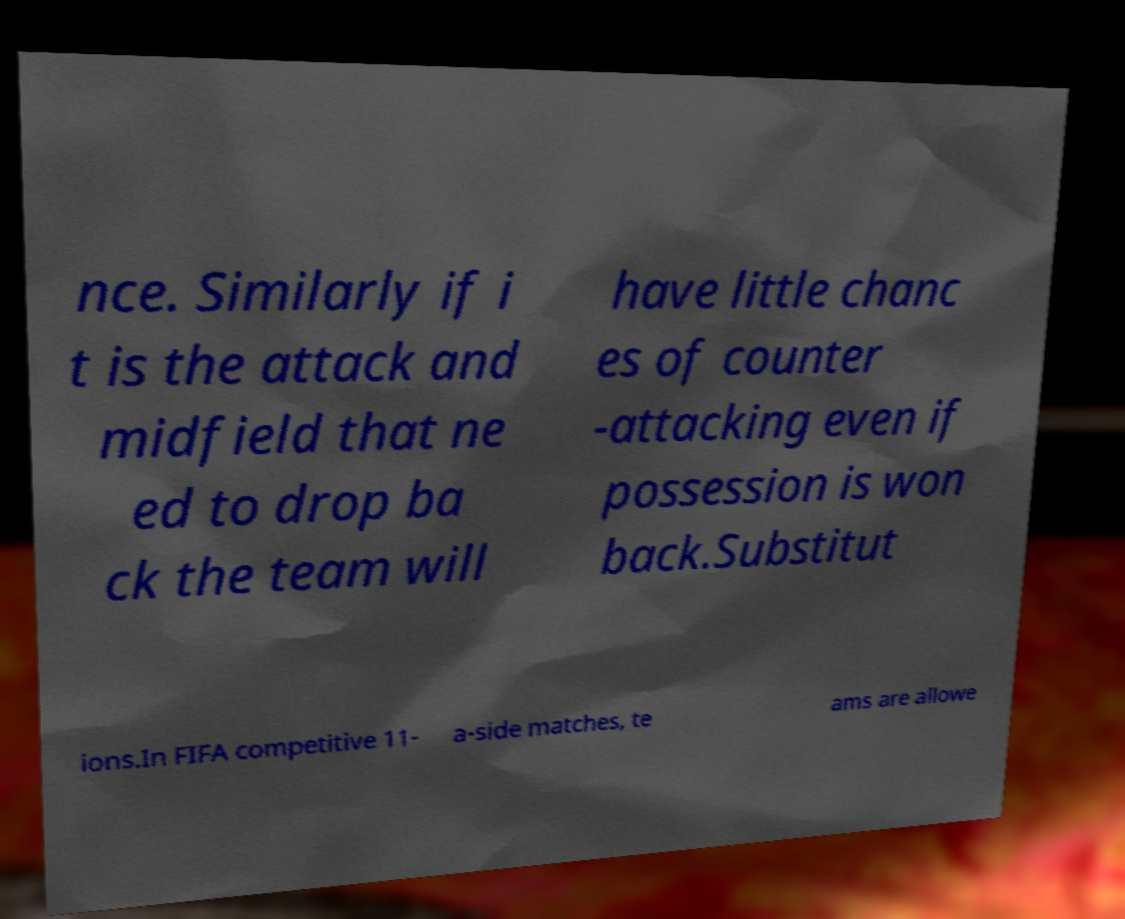I need the written content from this picture converted into text. Can you do that? nce. Similarly if i t is the attack and midfield that ne ed to drop ba ck the team will have little chanc es of counter -attacking even if possession is won back.Substitut ions.In FIFA competitive 11- a-side matches, te ams are allowe 